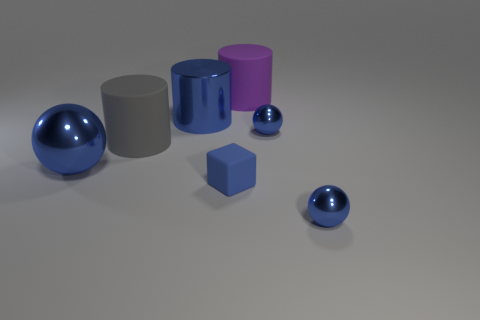Subtract all big blue metal balls. How many balls are left? 2 Subtract all blue cylinders. How many cylinders are left? 2 Subtract 1 balls. How many balls are left? 2 Subtract all balls. How many objects are left? 4 Add 3 big shiny cylinders. How many objects exist? 10 Subtract all brown spheres. How many purple cubes are left? 0 Add 7 big blue metal spheres. How many big blue metal spheres are left? 8 Add 4 small green matte cylinders. How many small green matte cylinders exist? 4 Subtract 1 purple cylinders. How many objects are left? 6 Subtract all green cylinders. Subtract all brown blocks. How many cylinders are left? 3 